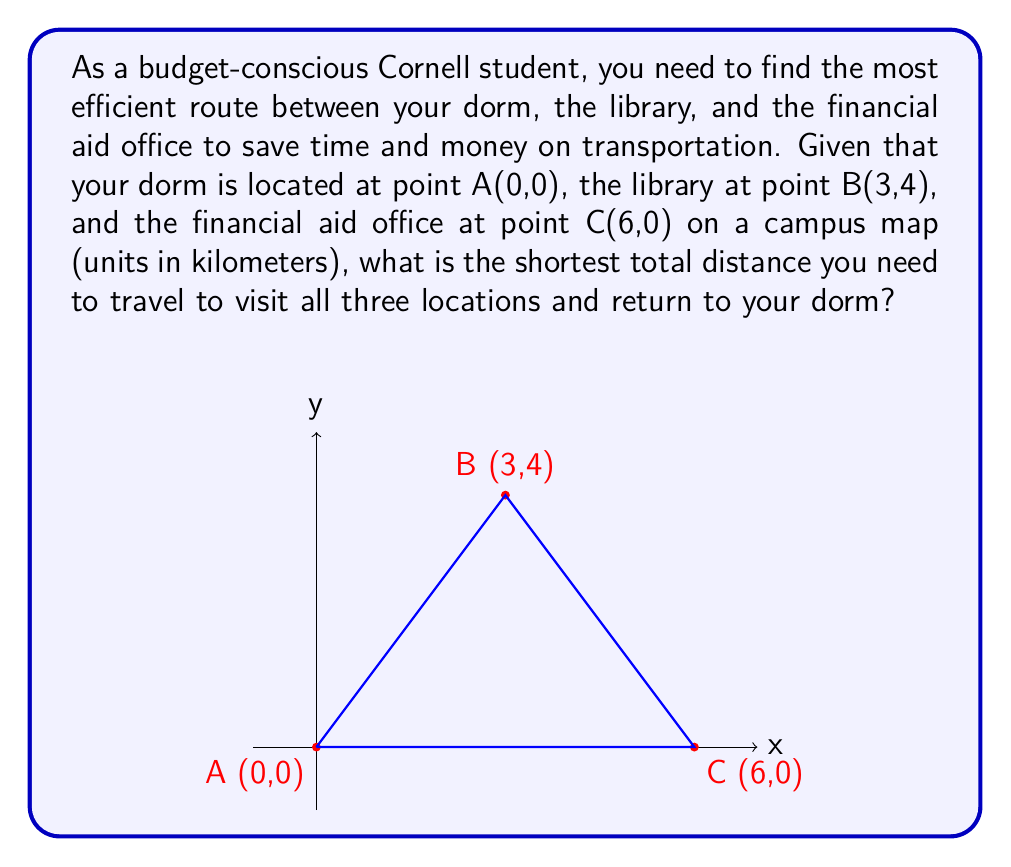Teach me how to tackle this problem. Let's approach this step-by-step:

1) First, we need to calculate the distances between each pair of points using the distance formula:
   $d = \sqrt{(x_2-x_1)^2 + (y_2-y_1)^2}$

2) Distance AB:
   $AB = \sqrt{(3-0)^2 + (4-0)^2} = \sqrt{9 + 16} = \sqrt{25} = 5$ km

3) Distance BC:
   $BC = \sqrt{(6-3)^2 + (0-4)^2} = \sqrt{9 + 16} = \sqrt{25} = 5$ km

4) Distance AC:
   $AC = \sqrt{(6-0)^2 + (0-0)^2} = \sqrt{36 + 0} = 6$ km

5) Now, we need to find the shortest path that visits all three points and returns to A. There are two possible routes:
   a) A → B → C → A
   b) A → C → B → A

6) Route a: A → B → C → A
   Total distance = AB + BC + CA = 5 + 5 + 6 = 16 km

7) Route b: A → C → B → A
   Total distance = AC + CB + BA = 6 + 5 + 5 = 16 km

8) Both routes have the same total distance, so either can be chosen as the shortest path.
Answer: 16 km 